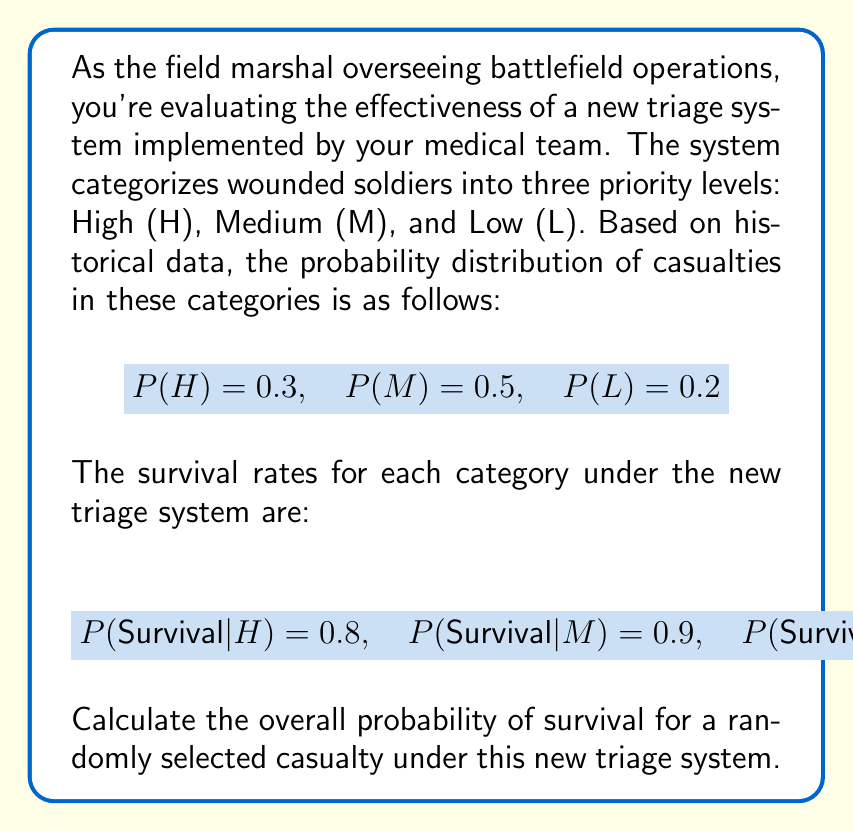What is the answer to this math problem? To solve this problem, we'll use the law of total probability. Let's break it down step-by-step:

1) The law of total probability states:

   $$P(\text{Survival}) = P(\text{Survival}|H) \cdot P(H) + P(\text{Survival}|M) \cdot P(M) + P(\text{Survival}|L) \cdot P(L)$$

2) We're given all the necessary probabilities:
   
   $$P(H) = 0.3, P(M) = 0.5, P(L) = 0.2$$
   $$P(\text{Survival}|H) = 0.8, P(\text{Survival}|M) = 0.9, P(\text{Survival}|L) = 0.95$$

3) Let's substitute these values into the formula:

   $$P(\text{Survival}) = (0.8 \cdot 0.3) + (0.9 \cdot 0.5) + (0.95 \cdot 0.2)$$

4) Now, let's calculate each term:
   
   $$P(\text{Survival}) = 0.24 + 0.45 + 0.19$$

5) Finally, sum up the terms:

   $$P(\text{Survival}) = 0.88$$

Therefore, the overall probability of survival for a randomly selected casualty under this new triage system is 0.88 or 88%.
Answer: 0.88 